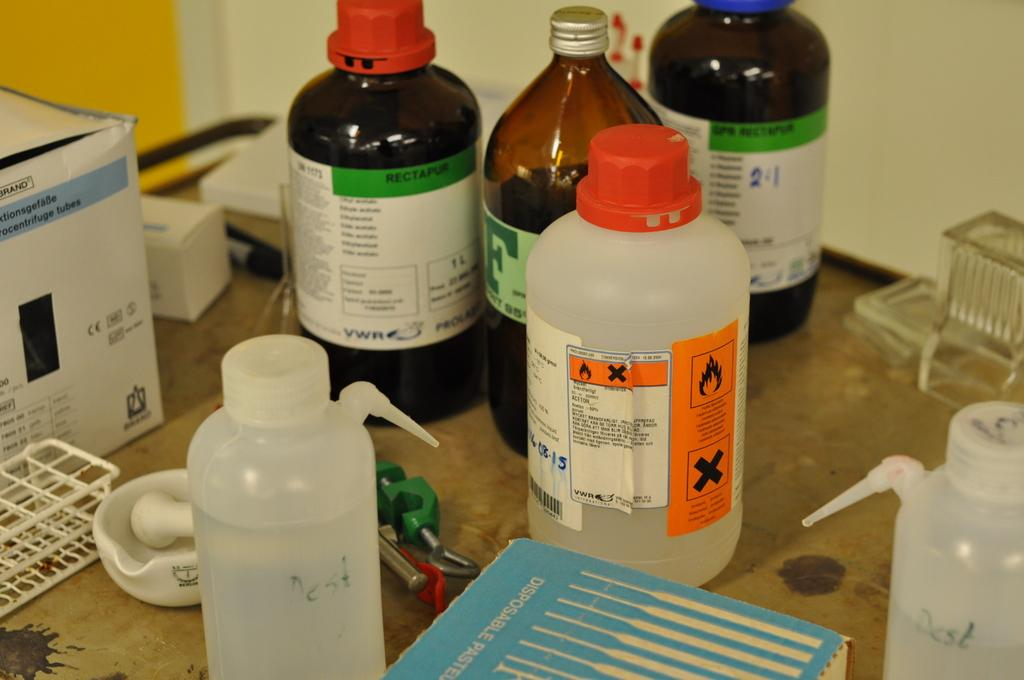<image>
Render a clear and concise summary of the photo. A table with medications on it, one brown bottle has a large F on it in green 